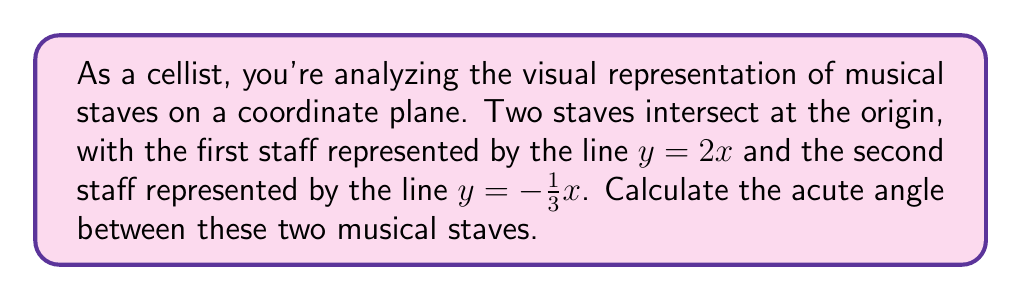Teach me how to tackle this problem. To find the angle between two lines on a coordinate plane, we can use the formula:

$$ \tan \theta = \left|\frac{m_1 - m_2}{1 + m_1m_2}\right| $$

Where $m_1$ and $m_2$ are the slopes of the two lines, and $\theta$ is the acute angle between them.

1. Identify the slopes:
   For the first line $y = 2x$, $m_1 = 2$
   For the second line $y = -\frac{1}{3}x$, $m_2 = -\frac{1}{3}$

2. Substitute these values into the formula:

   $$ \tan \theta = \left|\frac{2 - (-\frac{1}{3})}{1 + 2(-\frac{1}{3})}\right| $$

3. Simplify the numerator and denominator:

   $$ \tan \theta = \left|\frac{2 + \frac{1}{3}}{1 - \frac{2}{3}}\right| = \left|\frac{\frac{7}{3}}{\frac{1}{3}}\right| = 7 $$

4. Now we have $\tan \theta = 7$. To find $\theta$, we need to take the inverse tangent (arctangent):

   $$ \theta = \tan^{-1}(7) $$

5. Using a calculator or trigonometric tables:

   $$ \theta \approx 81.87^\circ $$

Thus, the acute angle between the two musical staves is approximately 81.87°.
Answer: $81.87^\circ$ (rounded to two decimal places) 